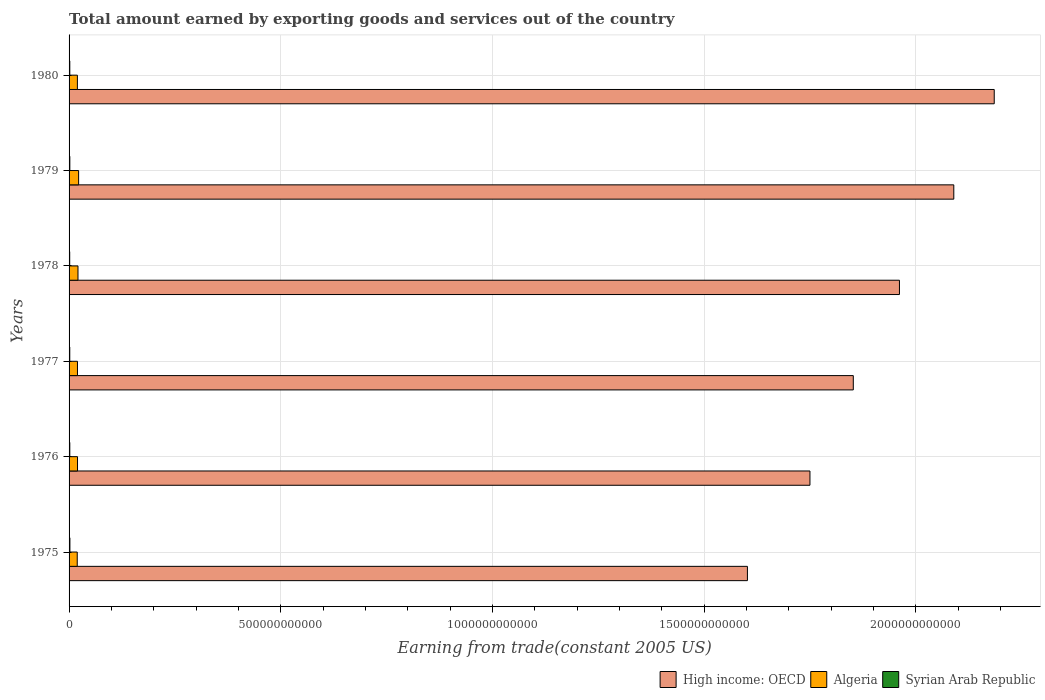Are the number of bars per tick equal to the number of legend labels?
Offer a very short reply. Yes. Are the number of bars on each tick of the Y-axis equal?
Your answer should be very brief. Yes. What is the label of the 3rd group of bars from the top?
Provide a succinct answer. 1978. In how many cases, is the number of bars for a given year not equal to the number of legend labels?
Your answer should be compact. 0. What is the total amount earned by exporting goods and services in Syrian Arab Republic in 1976?
Provide a succinct answer. 1.70e+09. Across all years, what is the maximum total amount earned by exporting goods and services in Algeria?
Offer a very short reply. 2.26e+1. Across all years, what is the minimum total amount earned by exporting goods and services in High income: OECD?
Keep it short and to the point. 1.60e+12. In which year was the total amount earned by exporting goods and services in Algeria maximum?
Provide a succinct answer. 1979. In which year was the total amount earned by exporting goods and services in High income: OECD minimum?
Keep it short and to the point. 1975. What is the total total amount earned by exporting goods and services in High income: OECD in the graph?
Offer a terse response. 1.14e+13. What is the difference between the total amount earned by exporting goods and services in Syrian Arab Republic in 1976 and that in 1978?
Make the answer very short. 1.98e+08. What is the difference between the total amount earned by exporting goods and services in Syrian Arab Republic in 1980 and the total amount earned by exporting goods and services in Algeria in 1976?
Make the answer very short. -1.82e+1. What is the average total amount earned by exporting goods and services in Algeria per year?
Provide a short and direct response. 2.04e+1. In the year 1975, what is the difference between the total amount earned by exporting goods and services in High income: OECD and total amount earned by exporting goods and services in Syrian Arab Republic?
Your answer should be compact. 1.60e+12. What is the ratio of the total amount earned by exporting goods and services in Algeria in 1978 to that in 1979?
Give a very brief answer. 0.93. Is the total amount earned by exporting goods and services in Syrian Arab Republic in 1975 less than that in 1976?
Offer a terse response. No. Is the difference between the total amount earned by exporting goods and services in High income: OECD in 1976 and 1978 greater than the difference between the total amount earned by exporting goods and services in Syrian Arab Republic in 1976 and 1978?
Provide a succinct answer. No. What is the difference between the highest and the second highest total amount earned by exporting goods and services in Syrian Arab Republic?
Provide a short and direct response. 1.78e+08. What is the difference between the highest and the lowest total amount earned by exporting goods and services in Syrian Arab Republic?
Give a very brief answer. 4.73e+08. What does the 1st bar from the top in 1977 represents?
Offer a very short reply. Syrian Arab Republic. What does the 3rd bar from the bottom in 1978 represents?
Keep it short and to the point. Syrian Arab Republic. Is it the case that in every year, the sum of the total amount earned by exporting goods and services in Algeria and total amount earned by exporting goods and services in Syrian Arab Republic is greater than the total amount earned by exporting goods and services in High income: OECD?
Offer a very short reply. No. Are all the bars in the graph horizontal?
Offer a very short reply. Yes. What is the difference between two consecutive major ticks on the X-axis?
Your answer should be compact. 5.00e+11. Are the values on the major ticks of X-axis written in scientific E-notation?
Offer a very short reply. No. Does the graph contain any zero values?
Provide a short and direct response. No. How many legend labels are there?
Your response must be concise. 3. What is the title of the graph?
Provide a succinct answer. Total amount earned by exporting goods and services out of the country. What is the label or title of the X-axis?
Your answer should be very brief. Earning from trade(constant 2005 US). What is the label or title of the Y-axis?
Offer a terse response. Years. What is the Earning from trade(constant 2005 US) in High income: OECD in 1975?
Offer a very short reply. 1.60e+12. What is the Earning from trade(constant 2005 US) of Algeria in 1975?
Provide a short and direct response. 1.93e+1. What is the Earning from trade(constant 2005 US) in Syrian Arab Republic in 1975?
Offer a terse response. 1.97e+09. What is the Earning from trade(constant 2005 US) of High income: OECD in 1976?
Your answer should be compact. 1.75e+12. What is the Earning from trade(constant 2005 US) of Algeria in 1976?
Provide a short and direct response. 2.00e+1. What is the Earning from trade(constant 2005 US) of Syrian Arab Republic in 1976?
Provide a succinct answer. 1.70e+09. What is the Earning from trade(constant 2005 US) of High income: OECD in 1977?
Ensure brevity in your answer.  1.85e+12. What is the Earning from trade(constant 2005 US) of Algeria in 1977?
Ensure brevity in your answer.  1.98e+1. What is the Earning from trade(constant 2005 US) in Syrian Arab Republic in 1977?
Ensure brevity in your answer.  1.64e+09. What is the Earning from trade(constant 2005 US) of High income: OECD in 1978?
Offer a very short reply. 1.96e+12. What is the Earning from trade(constant 2005 US) of Algeria in 1978?
Your answer should be compact. 2.10e+1. What is the Earning from trade(constant 2005 US) in Syrian Arab Republic in 1978?
Offer a very short reply. 1.50e+09. What is the Earning from trade(constant 2005 US) in High income: OECD in 1979?
Offer a very short reply. 2.09e+12. What is the Earning from trade(constant 2005 US) in Algeria in 1979?
Give a very brief answer. 2.26e+1. What is the Earning from trade(constant 2005 US) of Syrian Arab Republic in 1979?
Offer a terse response. 1.79e+09. What is the Earning from trade(constant 2005 US) of High income: OECD in 1980?
Your response must be concise. 2.19e+12. What is the Earning from trade(constant 2005 US) in Algeria in 1980?
Give a very brief answer. 1.96e+1. What is the Earning from trade(constant 2005 US) in Syrian Arab Republic in 1980?
Give a very brief answer. 1.72e+09. Across all years, what is the maximum Earning from trade(constant 2005 US) of High income: OECD?
Keep it short and to the point. 2.19e+12. Across all years, what is the maximum Earning from trade(constant 2005 US) in Algeria?
Provide a short and direct response. 2.26e+1. Across all years, what is the maximum Earning from trade(constant 2005 US) in Syrian Arab Republic?
Offer a terse response. 1.97e+09. Across all years, what is the minimum Earning from trade(constant 2005 US) in High income: OECD?
Ensure brevity in your answer.  1.60e+12. Across all years, what is the minimum Earning from trade(constant 2005 US) of Algeria?
Provide a succinct answer. 1.93e+1. Across all years, what is the minimum Earning from trade(constant 2005 US) in Syrian Arab Republic?
Your response must be concise. 1.50e+09. What is the total Earning from trade(constant 2005 US) of High income: OECD in the graph?
Ensure brevity in your answer.  1.14e+13. What is the total Earning from trade(constant 2005 US) in Algeria in the graph?
Ensure brevity in your answer.  1.22e+11. What is the total Earning from trade(constant 2005 US) of Syrian Arab Republic in the graph?
Provide a succinct answer. 1.03e+1. What is the difference between the Earning from trade(constant 2005 US) of High income: OECD in 1975 and that in 1976?
Provide a short and direct response. -1.48e+11. What is the difference between the Earning from trade(constant 2005 US) of Algeria in 1975 and that in 1976?
Your answer should be compact. -6.69e+08. What is the difference between the Earning from trade(constant 2005 US) of Syrian Arab Republic in 1975 and that in 1976?
Offer a very short reply. 2.75e+08. What is the difference between the Earning from trade(constant 2005 US) of High income: OECD in 1975 and that in 1977?
Make the answer very short. -2.50e+11. What is the difference between the Earning from trade(constant 2005 US) in Algeria in 1975 and that in 1977?
Keep it short and to the point. -5.63e+08. What is the difference between the Earning from trade(constant 2005 US) in Syrian Arab Republic in 1975 and that in 1977?
Give a very brief answer. 3.29e+08. What is the difference between the Earning from trade(constant 2005 US) of High income: OECD in 1975 and that in 1978?
Your answer should be compact. -3.59e+11. What is the difference between the Earning from trade(constant 2005 US) of Algeria in 1975 and that in 1978?
Make the answer very short. -1.76e+09. What is the difference between the Earning from trade(constant 2005 US) in Syrian Arab Republic in 1975 and that in 1978?
Ensure brevity in your answer.  4.73e+08. What is the difference between the Earning from trade(constant 2005 US) in High income: OECD in 1975 and that in 1979?
Give a very brief answer. -4.88e+11. What is the difference between the Earning from trade(constant 2005 US) in Algeria in 1975 and that in 1979?
Provide a short and direct response. -3.27e+09. What is the difference between the Earning from trade(constant 2005 US) of Syrian Arab Republic in 1975 and that in 1979?
Your response must be concise. 1.78e+08. What is the difference between the Earning from trade(constant 2005 US) of High income: OECD in 1975 and that in 1980?
Provide a short and direct response. -5.83e+11. What is the difference between the Earning from trade(constant 2005 US) of Algeria in 1975 and that in 1980?
Provide a succinct answer. -3.52e+08. What is the difference between the Earning from trade(constant 2005 US) in Syrian Arab Republic in 1975 and that in 1980?
Your answer should be compact. 2.49e+08. What is the difference between the Earning from trade(constant 2005 US) of High income: OECD in 1976 and that in 1977?
Provide a succinct answer. -1.02e+11. What is the difference between the Earning from trade(constant 2005 US) of Algeria in 1976 and that in 1977?
Give a very brief answer. 1.06e+08. What is the difference between the Earning from trade(constant 2005 US) of Syrian Arab Republic in 1976 and that in 1977?
Provide a succinct answer. 5.36e+07. What is the difference between the Earning from trade(constant 2005 US) of High income: OECD in 1976 and that in 1978?
Your answer should be very brief. -2.11e+11. What is the difference between the Earning from trade(constant 2005 US) of Algeria in 1976 and that in 1978?
Your answer should be compact. -1.09e+09. What is the difference between the Earning from trade(constant 2005 US) in Syrian Arab Republic in 1976 and that in 1978?
Your answer should be compact. 1.98e+08. What is the difference between the Earning from trade(constant 2005 US) of High income: OECD in 1976 and that in 1979?
Provide a succinct answer. -3.40e+11. What is the difference between the Earning from trade(constant 2005 US) in Algeria in 1976 and that in 1979?
Your answer should be very brief. -2.60e+09. What is the difference between the Earning from trade(constant 2005 US) in Syrian Arab Republic in 1976 and that in 1979?
Keep it short and to the point. -9.75e+07. What is the difference between the Earning from trade(constant 2005 US) in High income: OECD in 1976 and that in 1980?
Ensure brevity in your answer.  -4.35e+11. What is the difference between the Earning from trade(constant 2005 US) in Algeria in 1976 and that in 1980?
Your answer should be compact. 3.17e+08. What is the difference between the Earning from trade(constant 2005 US) in Syrian Arab Republic in 1976 and that in 1980?
Keep it short and to the point. -2.67e+07. What is the difference between the Earning from trade(constant 2005 US) of High income: OECD in 1977 and that in 1978?
Your answer should be very brief. -1.09e+11. What is the difference between the Earning from trade(constant 2005 US) of Algeria in 1977 and that in 1978?
Your answer should be very brief. -1.20e+09. What is the difference between the Earning from trade(constant 2005 US) of Syrian Arab Republic in 1977 and that in 1978?
Provide a succinct answer. 1.44e+08. What is the difference between the Earning from trade(constant 2005 US) in High income: OECD in 1977 and that in 1979?
Provide a short and direct response. -2.37e+11. What is the difference between the Earning from trade(constant 2005 US) of Algeria in 1977 and that in 1979?
Offer a terse response. -2.71e+09. What is the difference between the Earning from trade(constant 2005 US) of Syrian Arab Republic in 1977 and that in 1979?
Provide a succinct answer. -1.51e+08. What is the difference between the Earning from trade(constant 2005 US) in High income: OECD in 1977 and that in 1980?
Keep it short and to the point. -3.33e+11. What is the difference between the Earning from trade(constant 2005 US) of Algeria in 1977 and that in 1980?
Ensure brevity in your answer.  2.11e+08. What is the difference between the Earning from trade(constant 2005 US) in Syrian Arab Republic in 1977 and that in 1980?
Provide a succinct answer. -8.03e+07. What is the difference between the Earning from trade(constant 2005 US) in High income: OECD in 1978 and that in 1979?
Your answer should be very brief. -1.28e+11. What is the difference between the Earning from trade(constant 2005 US) of Algeria in 1978 and that in 1979?
Offer a very short reply. -1.51e+09. What is the difference between the Earning from trade(constant 2005 US) in Syrian Arab Republic in 1978 and that in 1979?
Keep it short and to the point. -2.95e+08. What is the difference between the Earning from trade(constant 2005 US) of High income: OECD in 1978 and that in 1980?
Keep it short and to the point. -2.24e+11. What is the difference between the Earning from trade(constant 2005 US) in Algeria in 1978 and that in 1980?
Ensure brevity in your answer.  1.41e+09. What is the difference between the Earning from trade(constant 2005 US) of Syrian Arab Republic in 1978 and that in 1980?
Your answer should be compact. -2.25e+08. What is the difference between the Earning from trade(constant 2005 US) in High income: OECD in 1979 and that in 1980?
Your answer should be very brief. -9.55e+1. What is the difference between the Earning from trade(constant 2005 US) in Algeria in 1979 and that in 1980?
Make the answer very short. 2.92e+09. What is the difference between the Earning from trade(constant 2005 US) in Syrian Arab Republic in 1979 and that in 1980?
Provide a succinct answer. 7.08e+07. What is the difference between the Earning from trade(constant 2005 US) in High income: OECD in 1975 and the Earning from trade(constant 2005 US) in Algeria in 1976?
Provide a short and direct response. 1.58e+12. What is the difference between the Earning from trade(constant 2005 US) in High income: OECD in 1975 and the Earning from trade(constant 2005 US) in Syrian Arab Republic in 1976?
Your response must be concise. 1.60e+12. What is the difference between the Earning from trade(constant 2005 US) of Algeria in 1975 and the Earning from trade(constant 2005 US) of Syrian Arab Republic in 1976?
Ensure brevity in your answer.  1.76e+1. What is the difference between the Earning from trade(constant 2005 US) in High income: OECD in 1975 and the Earning from trade(constant 2005 US) in Algeria in 1977?
Provide a succinct answer. 1.58e+12. What is the difference between the Earning from trade(constant 2005 US) in High income: OECD in 1975 and the Earning from trade(constant 2005 US) in Syrian Arab Republic in 1977?
Provide a short and direct response. 1.60e+12. What is the difference between the Earning from trade(constant 2005 US) in Algeria in 1975 and the Earning from trade(constant 2005 US) in Syrian Arab Republic in 1977?
Ensure brevity in your answer.  1.76e+1. What is the difference between the Earning from trade(constant 2005 US) of High income: OECD in 1975 and the Earning from trade(constant 2005 US) of Algeria in 1978?
Ensure brevity in your answer.  1.58e+12. What is the difference between the Earning from trade(constant 2005 US) in High income: OECD in 1975 and the Earning from trade(constant 2005 US) in Syrian Arab Republic in 1978?
Ensure brevity in your answer.  1.60e+12. What is the difference between the Earning from trade(constant 2005 US) in Algeria in 1975 and the Earning from trade(constant 2005 US) in Syrian Arab Republic in 1978?
Offer a very short reply. 1.78e+1. What is the difference between the Earning from trade(constant 2005 US) of High income: OECD in 1975 and the Earning from trade(constant 2005 US) of Algeria in 1979?
Your answer should be very brief. 1.58e+12. What is the difference between the Earning from trade(constant 2005 US) in High income: OECD in 1975 and the Earning from trade(constant 2005 US) in Syrian Arab Republic in 1979?
Keep it short and to the point. 1.60e+12. What is the difference between the Earning from trade(constant 2005 US) in Algeria in 1975 and the Earning from trade(constant 2005 US) in Syrian Arab Republic in 1979?
Make the answer very short. 1.75e+1. What is the difference between the Earning from trade(constant 2005 US) of High income: OECD in 1975 and the Earning from trade(constant 2005 US) of Algeria in 1980?
Your answer should be very brief. 1.58e+12. What is the difference between the Earning from trade(constant 2005 US) of High income: OECD in 1975 and the Earning from trade(constant 2005 US) of Syrian Arab Republic in 1980?
Your answer should be compact. 1.60e+12. What is the difference between the Earning from trade(constant 2005 US) of Algeria in 1975 and the Earning from trade(constant 2005 US) of Syrian Arab Republic in 1980?
Ensure brevity in your answer.  1.76e+1. What is the difference between the Earning from trade(constant 2005 US) in High income: OECD in 1976 and the Earning from trade(constant 2005 US) in Algeria in 1977?
Offer a very short reply. 1.73e+12. What is the difference between the Earning from trade(constant 2005 US) in High income: OECD in 1976 and the Earning from trade(constant 2005 US) in Syrian Arab Republic in 1977?
Your response must be concise. 1.75e+12. What is the difference between the Earning from trade(constant 2005 US) of Algeria in 1976 and the Earning from trade(constant 2005 US) of Syrian Arab Republic in 1977?
Keep it short and to the point. 1.83e+1. What is the difference between the Earning from trade(constant 2005 US) of High income: OECD in 1976 and the Earning from trade(constant 2005 US) of Algeria in 1978?
Offer a very short reply. 1.73e+12. What is the difference between the Earning from trade(constant 2005 US) of High income: OECD in 1976 and the Earning from trade(constant 2005 US) of Syrian Arab Republic in 1978?
Your response must be concise. 1.75e+12. What is the difference between the Earning from trade(constant 2005 US) in Algeria in 1976 and the Earning from trade(constant 2005 US) in Syrian Arab Republic in 1978?
Provide a succinct answer. 1.85e+1. What is the difference between the Earning from trade(constant 2005 US) of High income: OECD in 1976 and the Earning from trade(constant 2005 US) of Algeria in 1979?
Offer a terse response. 1.73e+12. What is the difference between the Earning from trade(constant 2005 US) in High income: OECD in 1976 and the Earning from trade(constant 2005 US) in Syrian Arab Republic in 1979?
Give a very brief answer. 1.75e+12. What is the difference between the Earning from trade(constant 2005 US) in Algeria in 1976 and the Earning from trade(constant 2005 US) in Syrian Arab Republic in 1979?
Your response must be concise. 1.82e+1. What is the difference between the Earning from trade(constant 2005 US) of High income: OECD in 1976 and the Earning from trade(constant 2005 US) of Algeria in 1980?
Ensure brevity in your answer.  1.73e+12. What is the difference between the Earning from trade(constant 2005 US) of High income: OECD in 1976 and the Earning from trade(constant 2005 US) of Syrian Arab Republic in 1980?
Provide a short and direct response. 1.75e+12. What is the difference between the Earning from trade(constant 2005 US) in Algeria in 1976 and the Earning from trade(constant 2005 US) in Syrian Arab Republic in 1980?
Ensure brevity in your answer.  1.82e+1. What is the difference between the Earning from trade(constant 2005 US) in High income: OECD in 1977 and the Earning from trade(constant 2005 US) in Algeria in 1978?
Make the answer very short. 1.83e+12. What is the difference between the Earning from trade(constant 2005 US) of High income: OECD in 1977 and the Earning from trade(constant 2005 US) of Syrian Arab Republic in 1978?
Provide a succinct answer. 1.85e+12. What is the difference between the Earning from trade(constant 2005 US) of Algeria in 1977 and the Earning from trade(constant 2005 US) of Syrian Arab Republic in 1978?
Keep it short and to the point. 1.83e+1. What is the difference between the Earning from trade(constant 2005 US) in High income: OECD in 1977 and the Earning from trade(constant 2005 US) in Algeria in 1979?
Offer a very short reply. 1.83e+12. What is the difference between the Earning from trade(constant 2005 US) of High income: OECD in 1977 and the Earning from trade(constant 2005 US) of Syrian Arab Republic in 1979?
Your response must be concise. 1.85e+12. What is the difference between the Earning from trade(constant 2005 US) of Algeria in 1977 and the Earning from trade(constant 2005 US) of Syrian Arab Republic in 1979?
Provide a short and direct response. 1.81e+1. What is the difference between the Earning from trade(constant 2005 US) in High income: OECD in 1977 and the Earning from trade(constant 2005 US) in Algeria in 1980?
Keep it short and to the point. 1.83e+12. What is the difference between the Earning from trade(constant 2005 US) in High income: OECD in 1977 and the Earning from trade(constant 2005 US) in Syrian Arab Republic in 1980?
Give a very brief answer. 1.85e+12. What is the difference between the Earning from trade(constant 2005 US) of Algeria in 1977 and the Earning from trade(constant 2005 US) of Syrian Arab Republic in 1980?
Provide a short and direct response. 1.81e+1. What is the difference between the Earning from trade(constant 2005 US) of High income: OECD in 1978 and the Earning from trade(constant 2005 US) of Algeria in 1979?
Ensure brevity in your answer.  1.94e+12. What is the difference between the Earning from trade(constant 2005 US) of High income: OECD in 1978 and the Earning from trade(constant 2005 US) of Syrian Arab Republic in 1979?
Your answer should be very brief. 1.96e+12. What is the difference between the Earning from trade(constant 2005 US) in Algeria in 1978 and the Earning from trade(constant 2005 US) in Syrian Arab Republic in 1979?
Offer a terse response. 1.93e+1. What is the difference between the Earning from trade(constant 2005 US) of High income: OECD in 1978 and the Earning from trade(constant 2005 US) of Algeria in 1980?
Provide a short and direct response. 1.94e+12. What is the difference between the Earning from trade(constant 2005 US) in High income: OECD in 1978 and the Earning from trade(constant 2005 US) in Syrian Arab Republic in 1980?
Your answer should be compact. 1.96e+12. What is the difference between the Earning from trade(constant 2005 US) in Algeria in 1978 and the Earning from trade(constant 2005 US) in Syrian Arab Republic in 1980?
Keep it short and to the point. 1.93e+1. What is the difference between the Earning from trade(constant 2005 US) of High income: OECD in 1979 and the Earning from trade(constant 2005 US) of Algeria in 1980?
Keep it short and to the point. 2.07e+12. What is the difference between the Earning from trade(constant 2005 US) of High income: OECD in 1979 and the Earning from trade(constant 2005 US) of Syrian Arab Republic in 1980?
Give a very brief answer. 2.09e+12. What is the difference between the Earning from trade(constant 2005 US) of Algeria in 1979 and the Earning from trade(constant 2005 US) of Syrian Arab Republic in 1980?
Ensure brevity in your answer.  2.08e+1. What is the average Earning from trade(constant 2005 US) in High income: OECD per year?
Offer a terse response. 1.91e+12. What is the average Earning from trade(constant 2005 US) of Algeria per year?
Your answer should be compact. 2.04e+1. What is the average Earning from trade(constant 2005 US) in Syrian Arab Republic per year?
Offer a terse response. 1.72e+09. In the year 1975, what is the difference between the Earning from trade(constant 2005 US) in High income: OECD and Earning from trade(constant 2005 US) in Algeria?
Ensure brevity in your answer.  1.58e+12. In the year 1975, what is the difference between the Earning from trade(constant 2005 US) of High income: OECD and Earning from trade(constant 2005 US) of Syrian Arab Republic?
Give a very brief answer. 1.60e+12. In the year 1975, what is the difference between the Earning from trade(constant 2005 US) of Algeria and Earning from trade(constant 2005 US) of Syrian Arab Republic?
Provide a succinct answer. 1.73e+1. In the year 1976, what is the difference between the Earning from trade(constant 2005 US) of High income: OECD and Earning from trade(constant 2005 US) of Algeria?
Your answer should be very brief. 1.73e+12. In the year 1976, what is the difference between the Earning from trade(constant 2005 US) of High income: OECD and Earning from trade(constant 2005 US) of Syrian Arab Republic?
Your answer should be very brief. 1.75e+12. In the year 1976, what is the difference between the Earning from trade(constant 2005 US) in Algeria and Earning from trade(constant 2005 US) in Syrian Arab Republic?
Ensure brevity in your answer.  1.83e+1. In the year 1977, what is the difference between the Earning from trade(constant 2005 US) in High income: OECD and Earning from trade(constant 2005 US) in Algeria?
Keep it short and to the point. 1.83e+12. In the year 1977, what is the difference between the Earning from trade(constant 2005 US) in High income: OECD and Earning from trade(constant 2005 US) in Syrian Arab Republic?
Offer a terse response. 1.85e+12. In the year 1977, what is the difference between the Earning from trade(constant 2005 US) in Algeria and Earning from trade(constant 2005 US) in Syrian Arab Republic?
Offer a very short reply. 1.82e+1. In the year 1978, what is the difference between the Earning from trade(constant 2005 US) in High income: OECD and Earning from trade(constant 2005 US) in Algeria?
Ensure brevity in your answer.  1.94e+12. In the year 1978, what is the difference between the Earning from trade(constant 2005 US) in High income: OECD and Earning from trade(constant 2005 US) in Syrian Arab Republic?
Your answer should be compact. 1.96e+12. In the year 1978, what is the difference between the Earning from trade(constant 2005 US) of Algeria and Earning from trade(constant 2005 US) of Syrian Arab Republic?
Your answer should be very brief. 1.95e+1. In the year 1979, what is the difference between the Earning from trade(constant 2005 US) of High income: OECD and Earning from trade(constant 2005 US) of Algeria?
Your response must be concise. 2.07e+12. In the year 1979, what is the difference between the Earning from trade(constant 2005 US) of High income: OECD and Earning from trade(constant 2005 US) of Syrian Arab Republic?
Ensure brevity in your answer.  2.09e+12. In the year 1979, what is the difference between the Earning from trade(constant 2005 US) in Algeria and Earning from trade(constant 2005 US) in Syrian Arab Republic?
Keep it short and to the point. 2.08e+1. In the year 1980, what is the difference between the Earning from trade(constant 2005 US) in High income: OECD and Earning from trade(constant 2005 US) in Algeria?
Make the answer very short. 2.17e+12. In the year 1980, what is the difference between the Earning from trade(constant 2005 US) in High income: OECD and Earning from trade(constant 2005 US) in Syrian Arab Republic?
Ensure brevity in your answer.  2.18e+12. In the year 1980, what is the difference between the Earning from trade(constant 2005 US) of Algeria and Earning from trade(constant 2005 US) of Syrian Arab Republic?
Your answer should be very brief. 1.79e+1. What is the ratio of the Earning from trade(constant 2005 US) of High income: OECD in 1975 to that in 1976?
Ensure brevity in your answer.  0.92. What is the ratio of the Earning from trade(constant 2005 US) in Algeria in 1975 to that in 1976?
Ensure brevity in your answer.  0.97. What is the ratio of the Earning from trade(constant 2005 US) of Syrian Arab Republic in 1975 to that in 1976?
Make the answer very short. 1.16. What is the ratio of the Earning from trade(constant 2005 US) in High income: OECD in 1975 to that in 1977?
Give a very brief answer. 0.86. What is the ratio of the Earning from trade(constant 2005 US) of Algeria in 1975 to that in 1977?
Your response must be concise. 0.97. What is the ratio of the Earning from trade(constant 2005 US) in Syrian Arab Republic in 1975 to that in 1977?
Your response must be concise. 1.2. What is the ratio of the Earning from trade(constant 2005 US) in High income: OECD in 1975 to that in 1978?
Your answer should be very brief. 0.82. What is the ratio of the Earning from trade(constant 2005 US) of Algeria in 1975 to that in 1978?
Offer a terse response. 0.92. What is the ratio of the Earning from trade(constant 2005 US) in Syrian Arab Republic in 1975 to that in 1978?
Your response must be concise. 1.32. What is the ratio of the Earning from trade(constant 2005 US) of High income: OECD in 1975 to that in 1979?
Offer a very short reply. 0.77. What is the ratio of the Earning from trade(constant 2005 US) in Algeria in 1975 to that in 1979?
Your response must be concise. 0.85. What is the ratio of the Earning from trade(constant 2005 US) of Syrian Arab Republic in 1975 to that in 1979?
Make the answer very short. 1.1. What is the ratio of the Earning from trade(constant 2005 US) in High income: OECD in 1975 to that in 1980?
Offer a very short reply. 0.73. What is the ratio of the Earning from trade(constant 2005 US) in Algeria in 1975 to that in 1980?
Make the answer very short. 0.98. What is the ratio of the Earning from trade(constant 2005 US) of Syrian Arab Republic in 1975 to that in 1980?
Keep it short and to the point. 1.14. What is the ratio of the Earning from trade(constant 2005 US) of High income: OECD in 1976 to that in 1977?
Ensure brevity in your answer.  0.94. What is the ratio of the Earning from trade(constant 2005 US) in Algeria in 1976 to that in 1977?
Provide a short and direct response. 1.01. What is the ratio of the Earning from trade(constant 2005 US) of Syrian Arab Republic in 1976 to that in 1977?
Provide a succinct answer. 1.03. What is the ratio of the Earning from trade(constant 2005 US) in High income: OECD in 1976 to that in 1978?
Make the answer very short. 0.89. What is the ratio of the Earning from trade(constant 2005 US) in Algeria in 1976 to that in 1978?
Offer a terse response. 0.95. What is the ratio of the Earning from trade(constant 2005 US) of Syrian Arab Republic in 1976 to that in 1978?
Make the answer very short. 1.13. What is the ratio of the Earning from trade(constant 2005 US) of High income: OECD in 1976 to that in 1979?
Ensure brevity in your answer.  0.84. What is the ratio of the Earning from trade(constant 2005 US) in Algeria in 1976 to that in 1979?
Your answer should be compact. 0.88. What is the ratio of the Earning from trade(constant 2005 US) in Syrian Arab Republic in 1976 to that in 1979?
Ensure brevity in your answer.  0.95. What is the ratio of the Earning from trade(constant 2005 US) of High income: OECD in 1976 to that in 1980?
Offer a very short reply. 0.8. What is the ratio of the Earning from trade(constant 2005 US) of Algeria in 1976 to that in 1980?
Keep it short and to the point. 1.02. What is the ratio of the Earning from trade(constant 2005 US) of Syrian Arab Republic in 1976 to that in 1980?
Provide a short and direct response. 0.98. What is the ratio of the Earning from trade(constant 2005 US) in High income: OECD in 1977 to that in 1978?
Give a very brief answer. 0.94. What is the ratio of the Earning from trade(constant 2005 US) of Algeria in 1977 to that in 1978?
Offer a terse response. 0.94. What is the ratio of the Earning from trade(constant 2005 US) of Syrian Arab Republic in 1977 to that in 1978?
Provide a short and direct response. 1.1. What is the ratio of the Earning from trade(constant 2005 US) in High income: OECD in 1977 to that in 1979?
Make the answer very short. 0.89. What is the ratio of the Earning from trade(constant 2005 US) in Algeria in 1977 to that in 1979?
Keep it short and to the point. 0.88. What is the ratio of the Earning from trade(constant 2005 US) of Syrian Arab Republic in 1977 to that in 1979?
Provide a short and direct response. 0.92. What is the ratio of the Earning from trade(constant 2005 US) of High income: OECD in 1977 to that in 1980?
Provide a short and direct response. 0.85. What is the ratio of the Earning from trade(constant 2005 US) of Algeria in 1977 to that in 1980?
Ensure brevity in your answer.  1.01. What is the ratio of the Earning from trade(constant 2005 US) in Syrian Arab Republic in 1977 to that in 1980?
Give a very brief answer. 0.95. What is the ratio of the Earning from trade(constant 2005 US) of High income: OECD in 1978 to that in 1979?
Your answer should be very brief. 0.94. What is the ratio of the Earning from trade(constant 2005 US) in Algeria in 1978 to that in 1979?
Offer a terse response. 0.93. What is the ratio of the Earning from trade(constant 2005 US) of Syrian Arab Republic in 1978 to that in 1979?
Your answer should be very brief. 0.84. What is the ratio of the Earning from trade(constant 2005 US) in High income: OECD in 1978 to that in 1980?
Your answer should be very brief. 0.9. What is the ratio of the Earning from trade(constant 2005 US) in Algeria in 1978 to that in 1980?
Your answer should be compact. 1.07. What is the ratio of the Earning from trade(constant 2005 US) in Syrian Arab Republic in 1978 to that in 1980?
Provide a succinct answer. 0.87. What is the ratio of the Earning from trade(constant 2005 US) in High income: OECD in 1979 to that in 1980?
Provide a succinct answer. 0.96. What is the ratio of the Earning from trade(constant 2005 US) of Algeria in 1979 to that in 1980?
Provide a short and direct response. 1.15. What is the ratio of the Earning from trade(constant 2005 US) of Syrian Arab Republic in 1979 to that in 1980?
Offer a very short reply. 1.04. What is the difference between the highest and the second highest Earning from trade(constant 2005 US) of High income: OECD?
Make the answer very short. 9.55e+1. What is the difference between the highest and the second highest Earning from trade(constant 2005 US) in Algeria?
Give a very brief answer. 1.51e+09. What is the difference between the highest and the second highest Earning from trade(constant 2005 US) in Syrian Arab Republic?
Give a very brief answer. 1.78e+08. What is the difference between the highest and the lowest Earning from trade(constant 2005 US) of High income: OECD?
Give a very brief answer. 5.83e+11. What is the difference between the highest and the lowest Earning from trade(constant 2005 US) in Algeria?
Provide a short and direct response. 3.27e+09. What is the difference between the highest and the lowest Earning from trade(constant 2005 US) in Syrian Arab Republic?
Make the answer very short. 4.73e+08. 